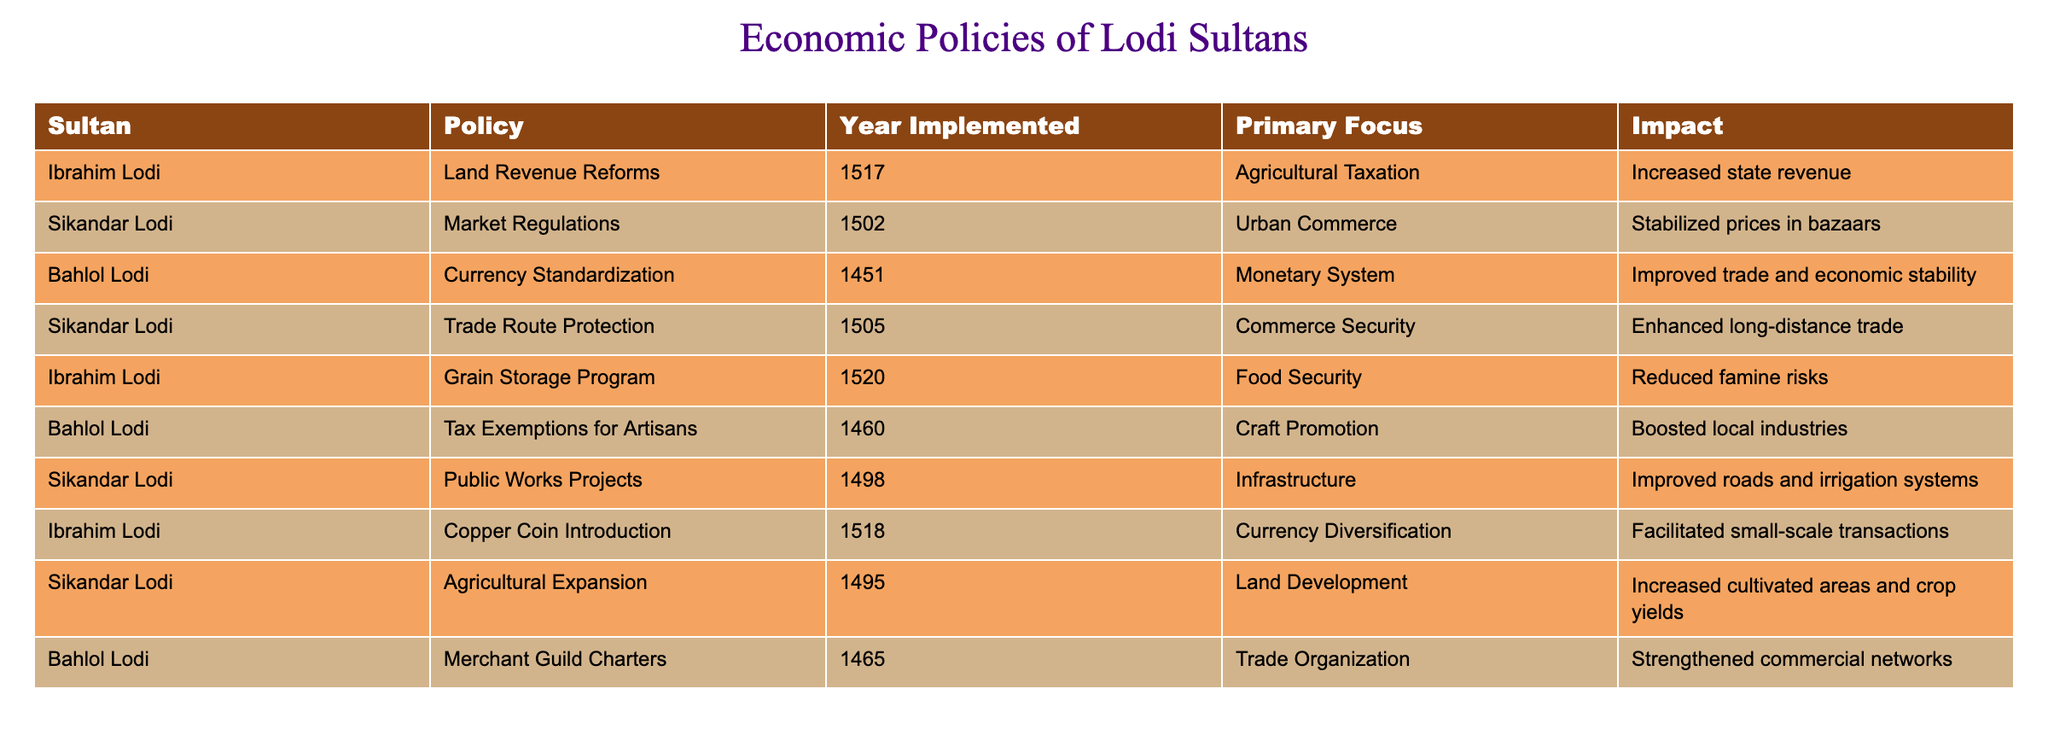What was the primary focus of the land revenue reforms implemented by Ibrahim Lodi? Ibrahim Lodi's land revenue reforms, which were implemented in 1517, had a primary focus on agricultural taxation. This means that the reforms specifically targeted taxation on agricultural produce or land usage related to agriculture.
Answer: Agricultural Taxation Which Sultan implemented market regulations in 1502? The table indicates that market regulations were implemented by Sikandar Lodi in 1502. This information is directly retrieved from the "Sultan" and "Year Implemented" columns.
Answer: Sikandar Lodi Was there any policy focused on currency standardization during Bahlol Lodi's reign? Yes, there was a policy focused on currency standardization during Bahlol Lodi's reign, implemented in 1451. This is confirmed by reviewing the relevant policy in the table.
Answer: Yes What is the impact of the grain storage program introduced by Ibrahim Lodi in 1520? The grain storage program, introduced by Ibrahim Lodi in 1520, aimed to reduce famine risks, as indicated in the "Impact" column. This shows that the program was intended to enhance food security.
Answer: Reduced famine risks What percentage of the policies listed in the table were aimed at improving trade and commerce? There are a total of 10 policies listed in the table, of which 4 directly focus on trade and commerce (market regulations, trade route protection, tax exemptions for artisans, merchant guild charters). To find the percentage, (4/10) * 100 = 40%. Therefore, 40% of the policies aimed at improving trade and commerce.
Answer: 40% What were the primary focuses of the public works projects initiated by Sikandar Lodi in 1498, and how did they impact the economy? The public works projects, initiated by Sikandar Lodi in 1498, had a primary focus on infrastructure, particularly improving roads and irrigation systems. This improvement in infrastructure would have had a positive impact on the economy by facilitating trade and agricultural productivity.
Answer: Infrastructure How many years apart were the currency changes introduced by Bahlol Lodi and Ibrahim Lodi? The currency standardization by Bahlol Lodi was introduced in 1451, while Ibrahim Lodi's copper coin introduction took place in 1518. To find the difference in years, subtract the earlier year from the later year: 1518 - 1451 = 67 years apart.
Answer: 67 years Did any of the policies implemented by the Lodi sultans focus on food security? Yes, one of the policies, specifically the grain storage program introduced by Ibrahim Lodi in 1520, focuses on food security, as indicated in the table under "Primary Focus."
Answer: Yes 